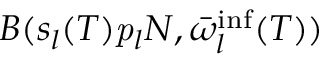<formula> <loc_0><loc_0><loc_500><loc_500>B ( s _ { l } ( T ) p _ { l } N , \bar { \omega } _ { l } ^ { i n f } ( T ) )</formula> 